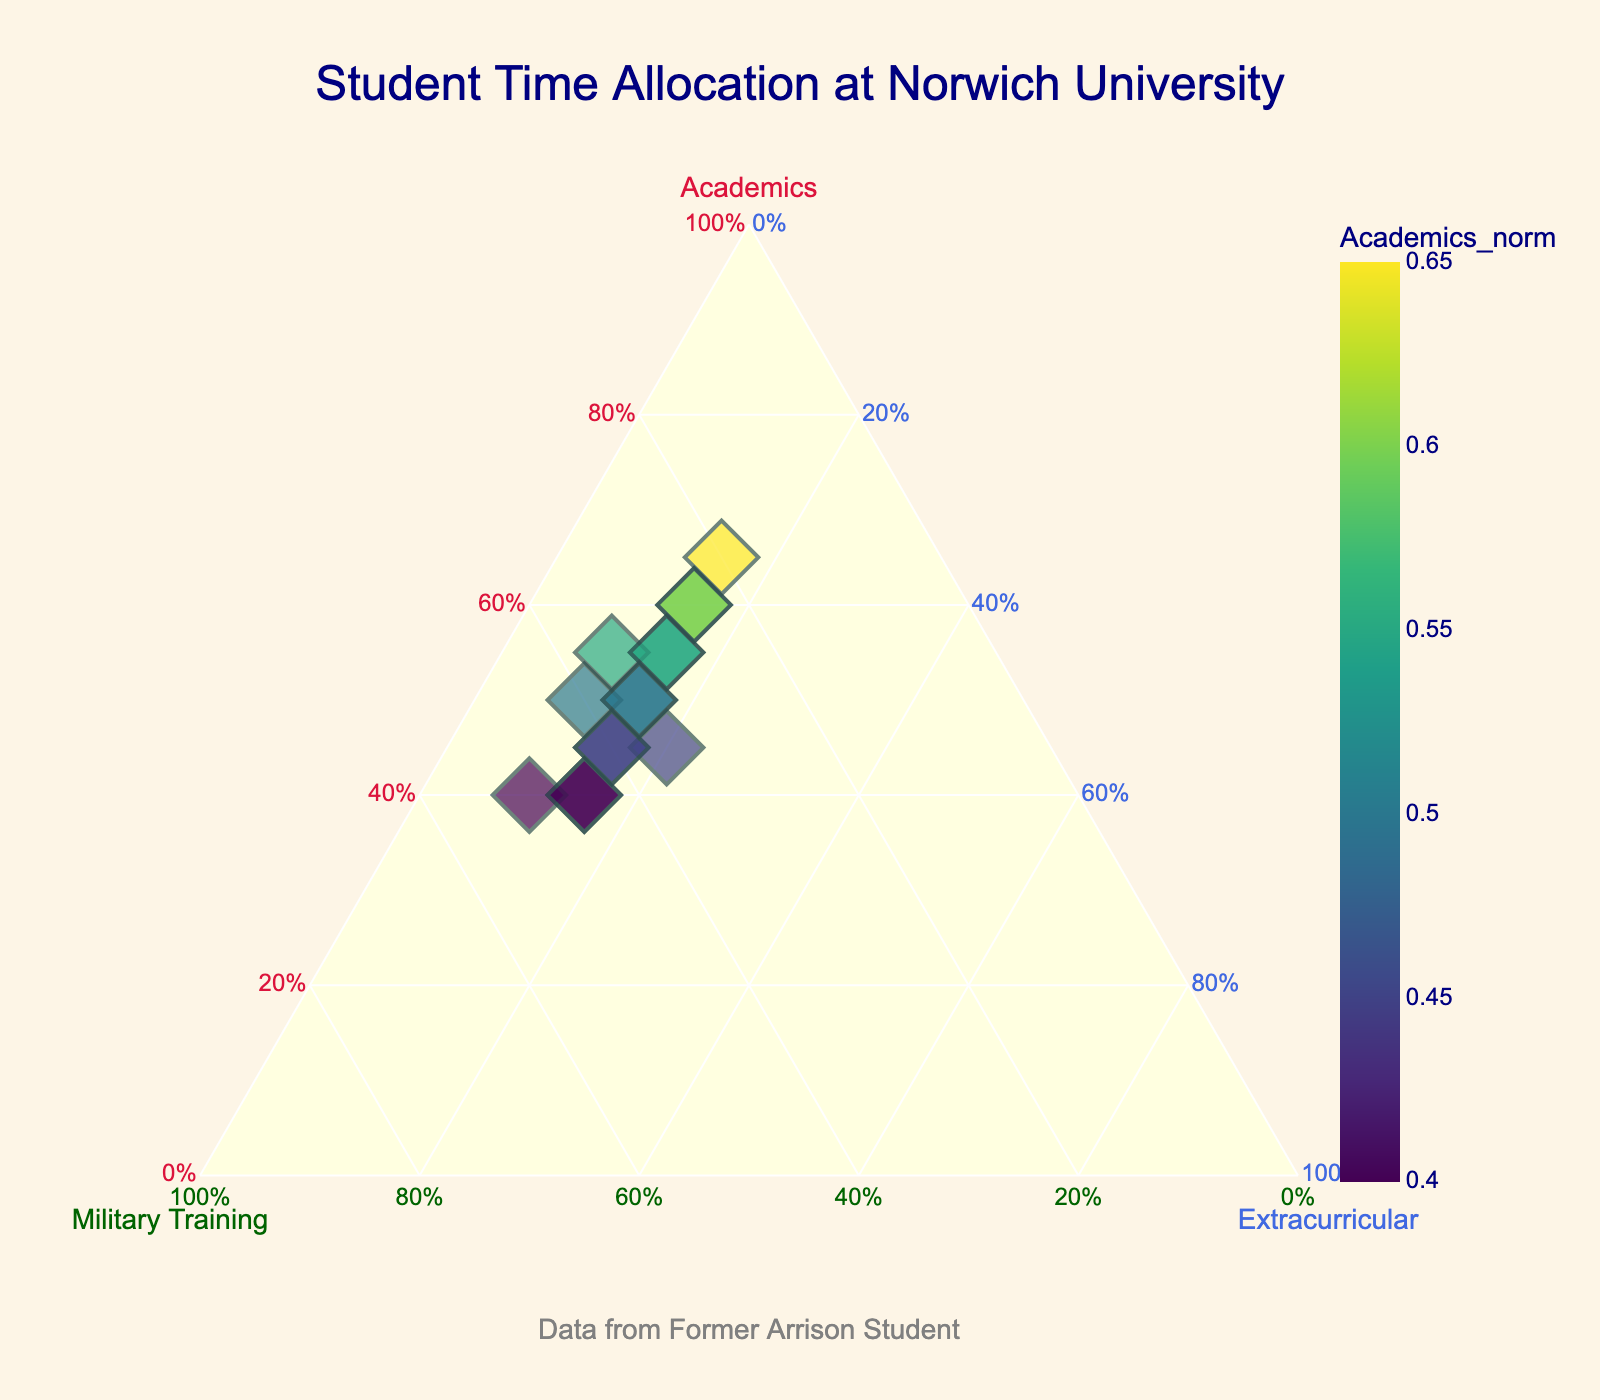What is the title of the ternary plot? The title is usually displayed at the top of the plot and provides a concise summary of what the figure represents.
Answer: Student Time Allocation at Norwich University Which axis on the ternary plot represents 'Academics'? The axis labels are on each corner of the ternary plot. The 'Academics' axis is identified by the label centered on the left corner of the plot.
Answer: The left axis What is the color used for the 'Military Training' axis? Axis colors are explicitly mentioned in the data. The 'Military Training' axis is indicated to be colored in dark green based on the code details.
Answer: dark green How many students have their total time allocation normalized for plotting purposes? The number of data points in the plot illustrates the number of individual entries in the dataset. By counting the unique entries (students), you can determine the total number included.
Answer: 15 students Which student allocated the most time to 'Academics'? By observing the points and hovering over them, we can identify which student is plotted furthest along the 'Academics' axis.
Answer: Amanda White Of the students plotted, who spent equal time on 'Military Training' and 'Academics'? Points that lie along a specific angle from the 'Academics' and 'Military Training' axes will show equal allocation for these two categories.
Answer: None What is the average percentage of time spent on 'Extracurricular Activities' for the students? The average can be found by summing the percentages of 'Extracurricular Activities' for all students, then dividing by the total number of students. (15% or 20%)
Answer: 14.67% Between Sarah Davis and Emily Collins, who dedicated more time to 'Military Training'? This involves comparing data points associated with these students, where the one plotted higher along the 'Military Training' axis dedicated more time.
Answer: Emily Collins For what reason might a student’s data point be colored differently in the plot? The coloring is based on the 'Academics_norm' value—the higher the normalized academics time, the different the shade on the Viridis color scale. We infer this from the plot coloring instructions.
Answer: Based on normalized 'Academics' time Which student is represented by the largest marker on the plot? Marker size correlates with the 'Total' value; the student with the highest total will have the largest marker. Observing the plot legend or hovering over points will confirm this.
Answer: Amanda White 